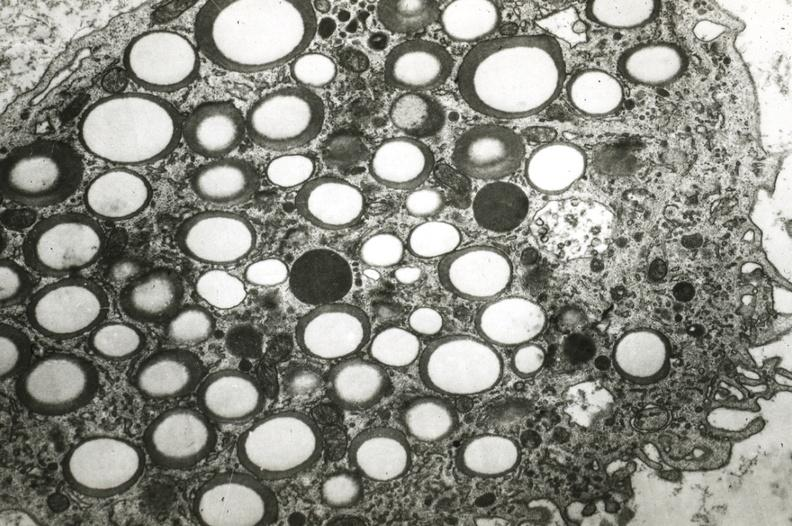s atrophy present?
Answer the question using a single word or phrase. No 